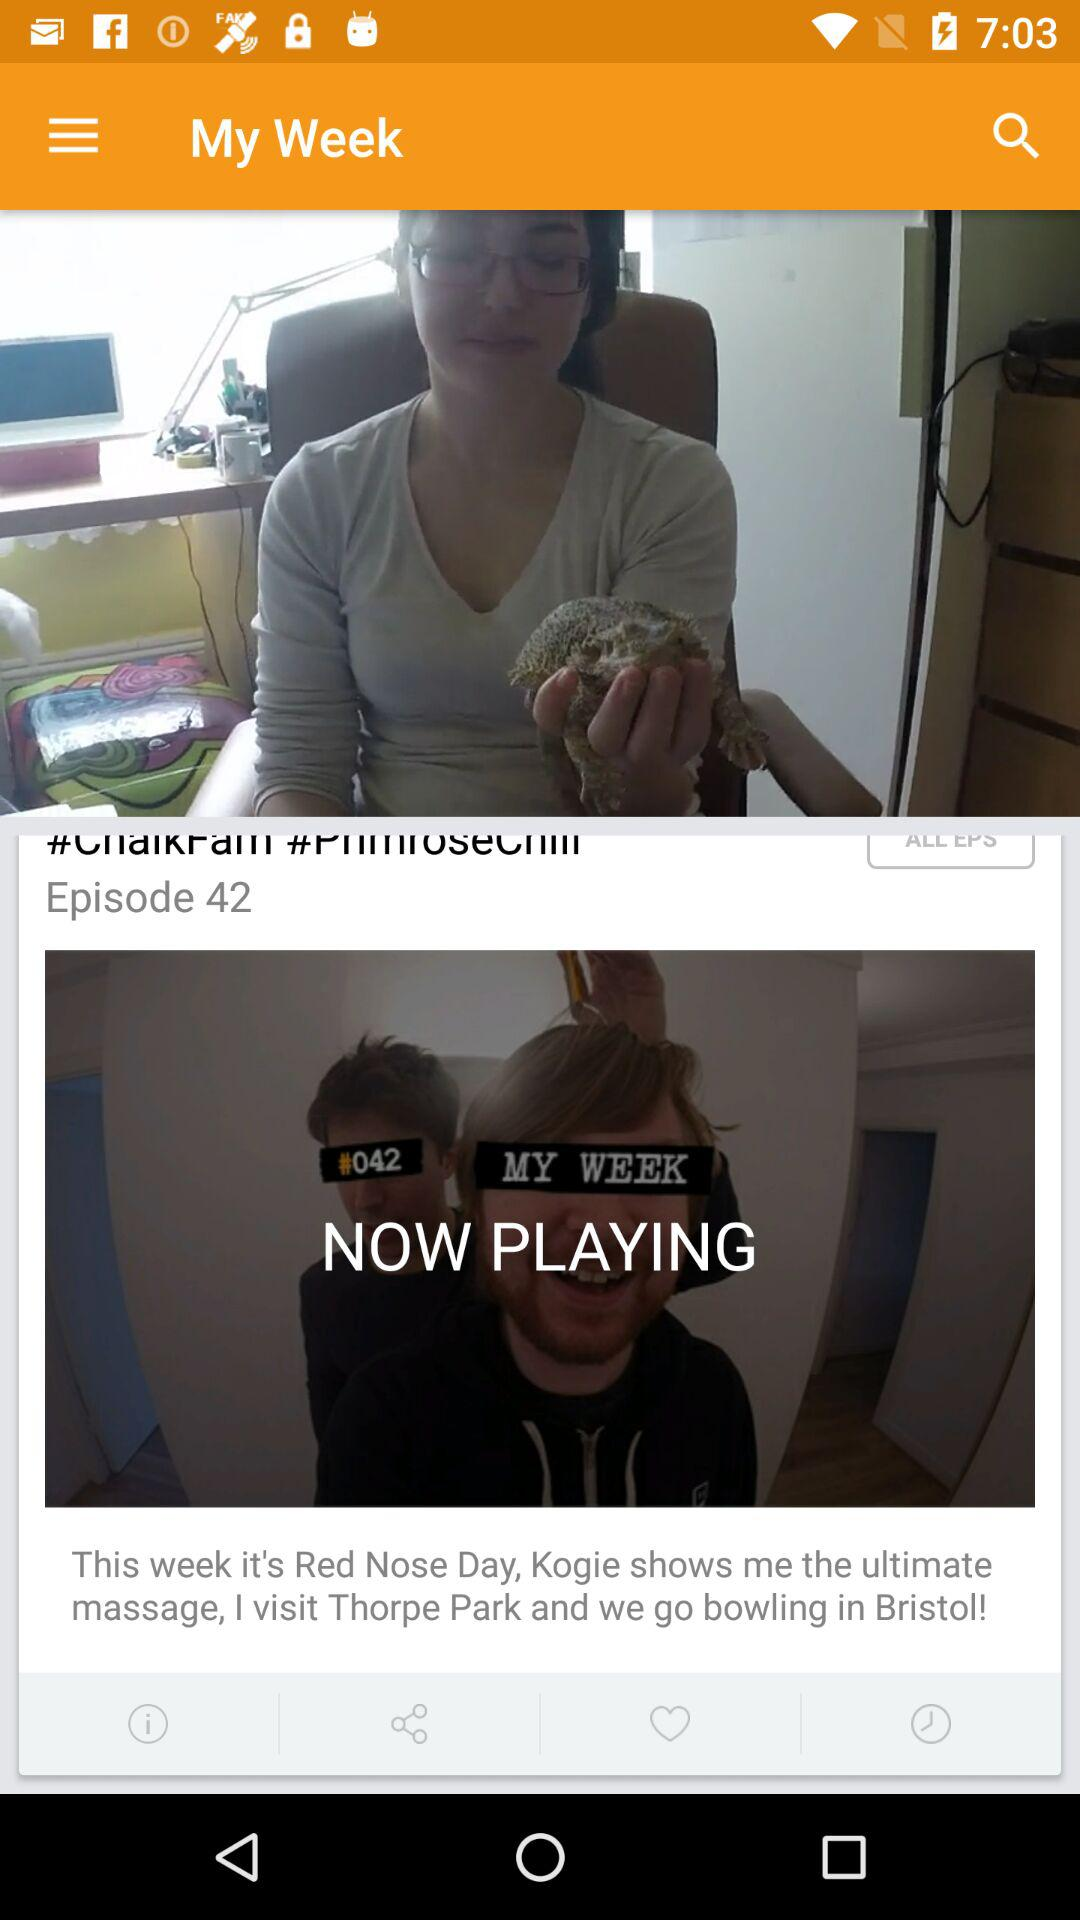How many episodes are there?
Answer the question using a single word or phrase. 42 